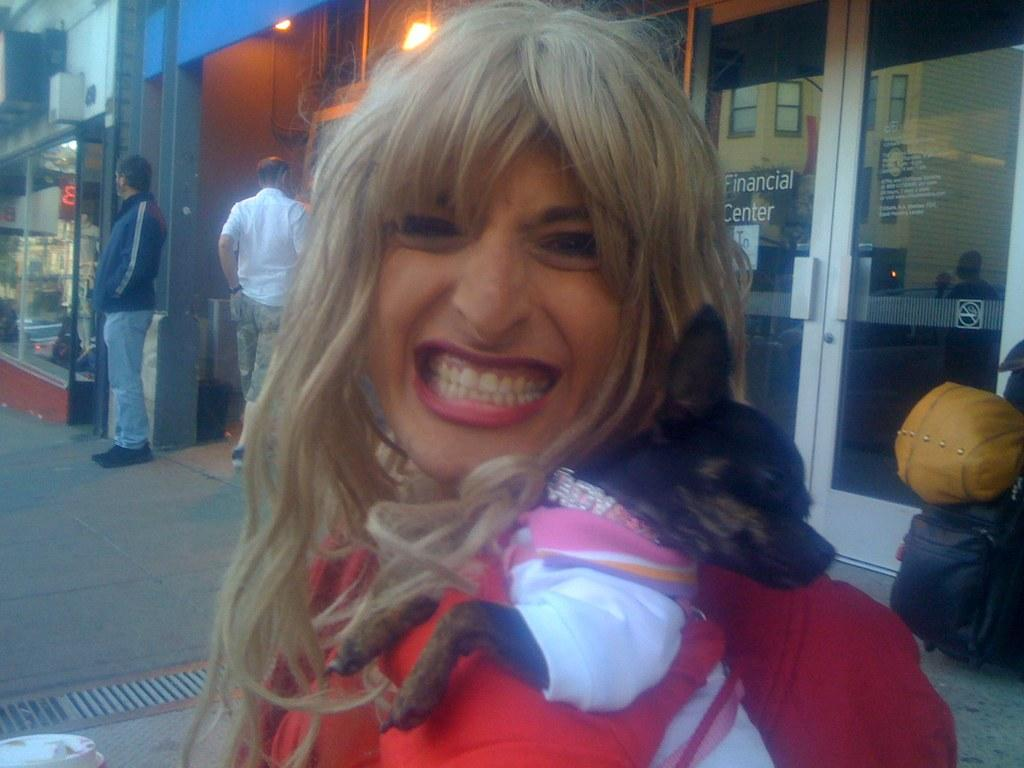Who is present in the image? There is a woman in the image. What is the woman doing? The woman is smiling and holding a dog with her hand. What else can be seen in the image? There are bags, two men on a path, lights, glass doors, windows, and some objects in the image. What type of science experiment is being conducted with the rabbit in the image? There is no rabbit present in the image, and therefore no science experiment can be observed. 